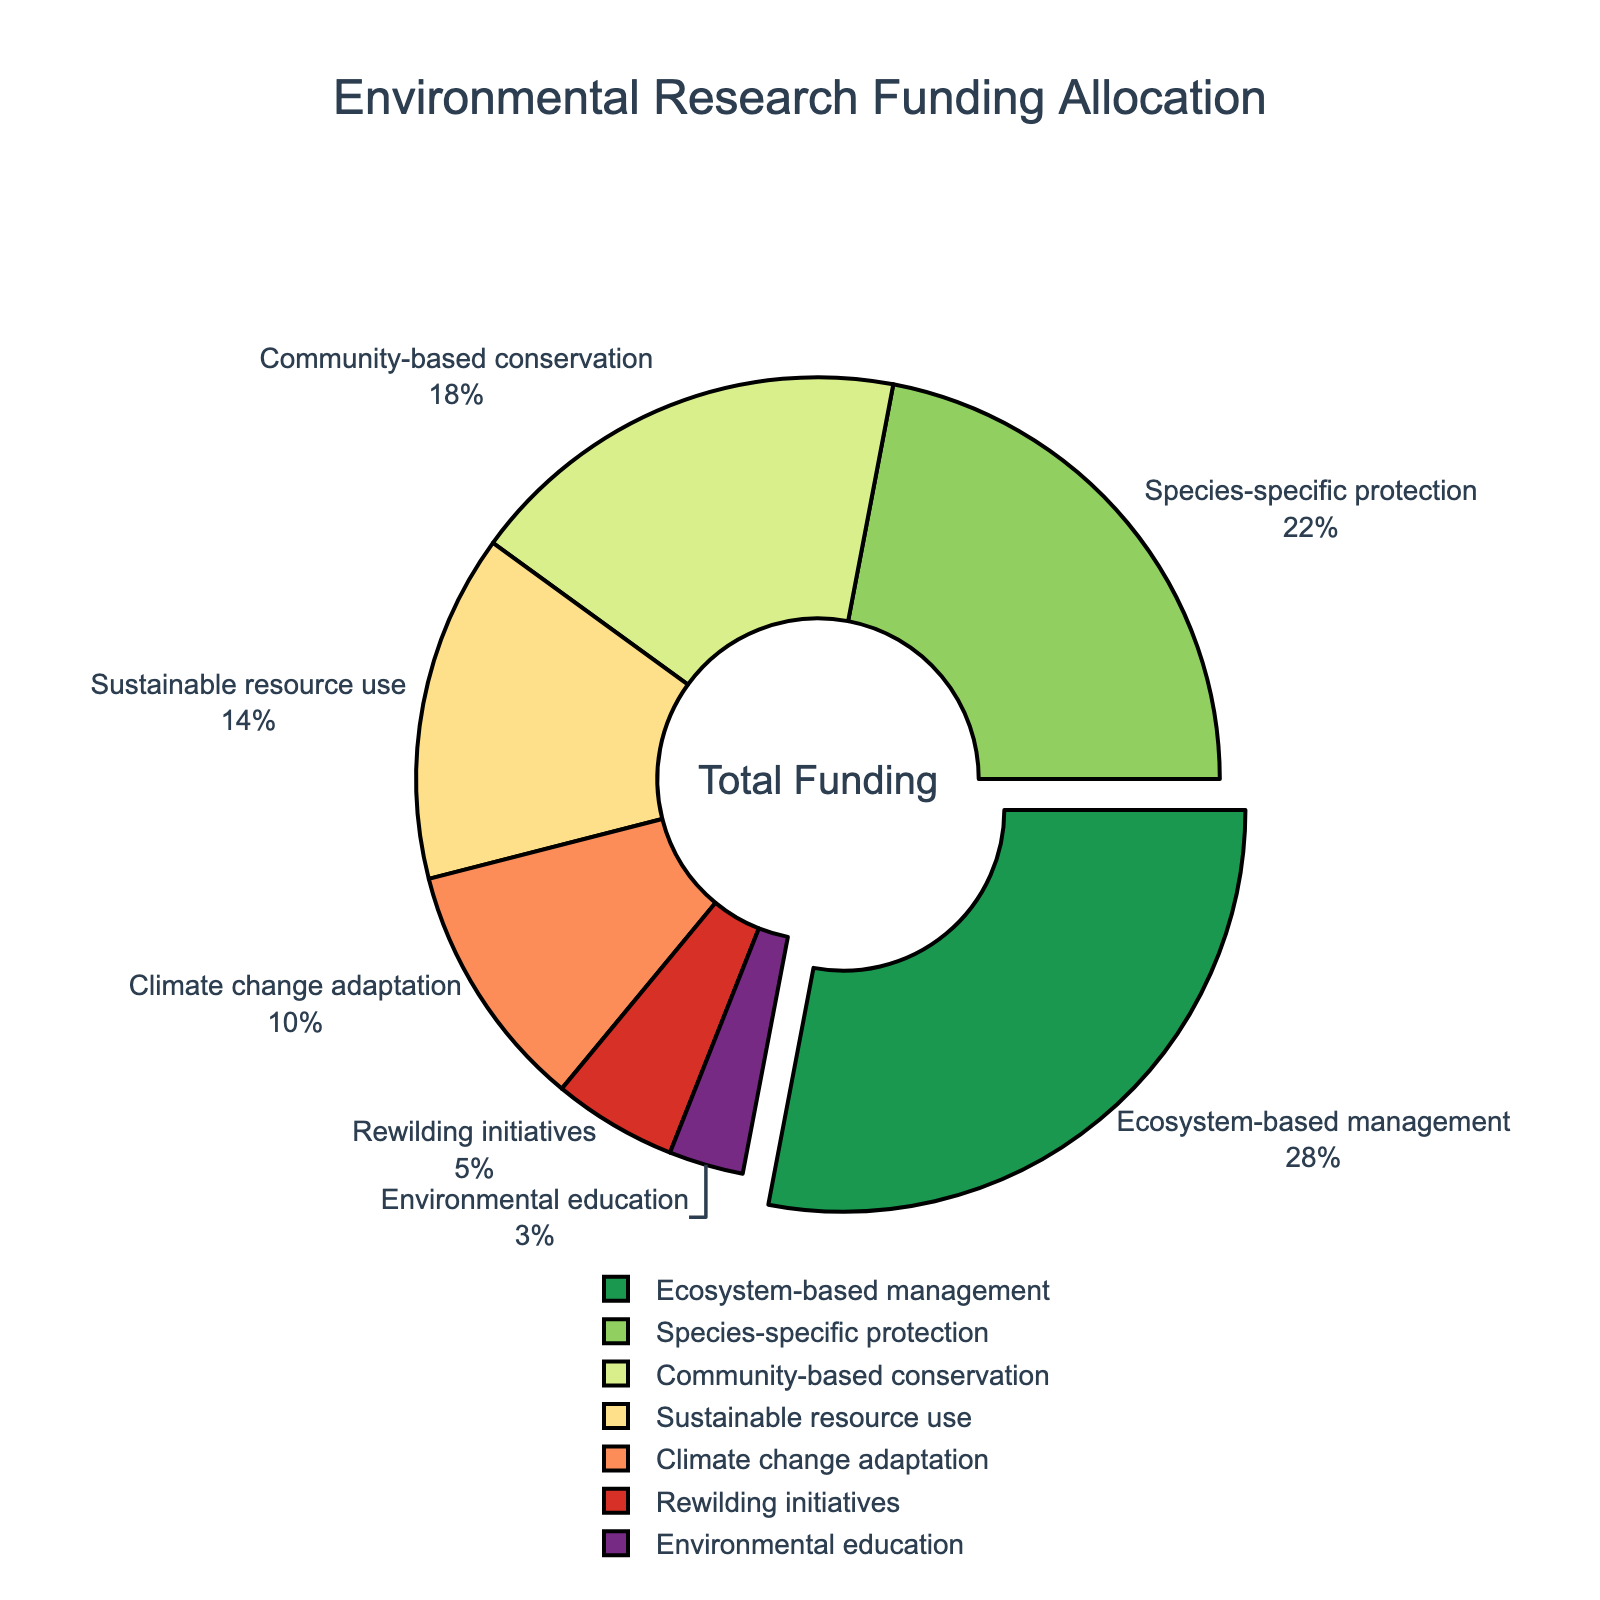Which conservation approach receives the most funding? The figure shows the percentage of funding allocated to each conservation approach, with "Ecosystem-based management" having the largest percentage.
Answer: Ecosystem-based management What percentage of funding is allocated to Climate change adaptation compared to Rewilding initiatives? The figure indicates that Climate change adaptation receives 10% of the funding while Rewilding initiatives receive 5%. Comparing these values shows that Climate change adaptation receives twice the funding as Rewilding initiatives.
Answer: Climate change adaptation receives twice the funding as Rewilding initiatives What is the total percentage of funding allocated to Community-based conservation and Environmental education combined? According to the figure, Community-based conservation receives 18% and Environmental education receives 3%. Adding these two percentages together gives 18% + 3% = 21%.
Answer: 21% Which conservation approach is highlighted (or stands out) in the figure and why? The figure uses a visual attribute to highlight the sector with the largest funding. "Ecosystem-based management" stands out due to a slight pull-out effect as it has the highest funding percentage, 28%.
Answer: Ecosystem-based management is highlighted How does the funding for Species-specific protection compare to Sustainable resource use? The figure shows that Species-specific protection receives 22% of the funding, whereas Sustainable resource use gets 14%. Thus, Species-specific protection receives 8% more funding than Sustainable resource use.
Answer: Species-specific protection receives 8% more funding What is the median funding percentage allocated across all conservation approaches? To find the median, list the percentages in ascending order: 3%, 5%, 10%, 14%, 18%, 22%, 28%. The median is the middle value of this ordered list, which is 14%.
Answer: 14% What is the ratio of funding between the top two funded approaches? The top two funded approaches are Ecosystem-based management (28%) and Species-specific protection (22%). The ratio of their funding would be 28:22, which simplifies to 14:11.
Answer: 14:11 What is the cumulative funding percentage for the least three funded conservation approaches? The least three funded approaches are Rewilding initiatives (5%), Environmental education (3%), and Climate change adaptation (10%). Summing these gives 5% + 3% + 10% = 18%.
Answer: 18% 